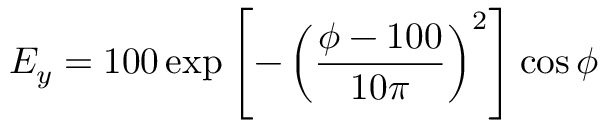<formula> <loc_0><loc_0><loc_500><loc_500>E _ { y } = 1 0 0 \exp \left [ - \left ( \frac { \phi - 1 0 0 } { 1 0 \pi } \right ) ^ { 2 } \right ] \cos \phi</formula> 